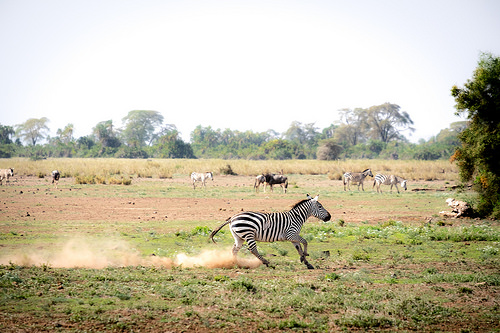<image>
Can you confirm if the zebra is in the ground? No. The zebra is not contained within the ground. These objects have a different spatial relationship. 